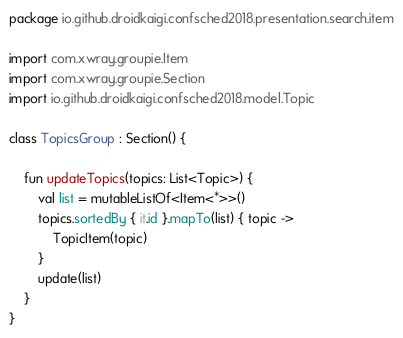Convert code to text. <code><loc_0><loc_0><loc_500><loc_500><_Kotlin_>package io.github.droidkaigi.confsched2018.presentation.search.item

import com.xwray.groupie.Item
import com.xwray.groupie.Section
import io.github.droidkaigi.confsched2018.model.Topic

class TopicsGroup : Section() {

    fun updateTopics(topics: List<Topic>) {
        val list = mutableListOf<Item<*>>()
        topics.sortedBy { it.id }.mapTo(list) { topic ->
            TopicItem(topic)
        }
        update(list)
    }
}
</code> 